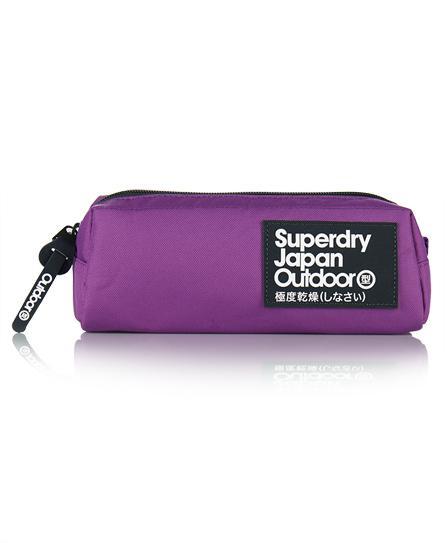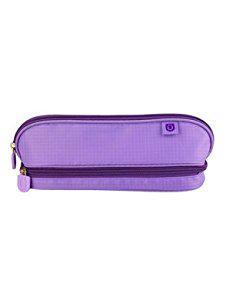The first image is the image on the left, the second image is the image on the right. Considering the images on both sides, is "The pencil case in one of the images in purple and the other is pink." valid? Answer yes or no. No. The first image is the image on the left, the second image is the image on the right. Evaluate the accuracy of this statement regarding the images: "There is one purple pencil case and one hot pink pencil case.". Is it true? Answer yes or no. No. 